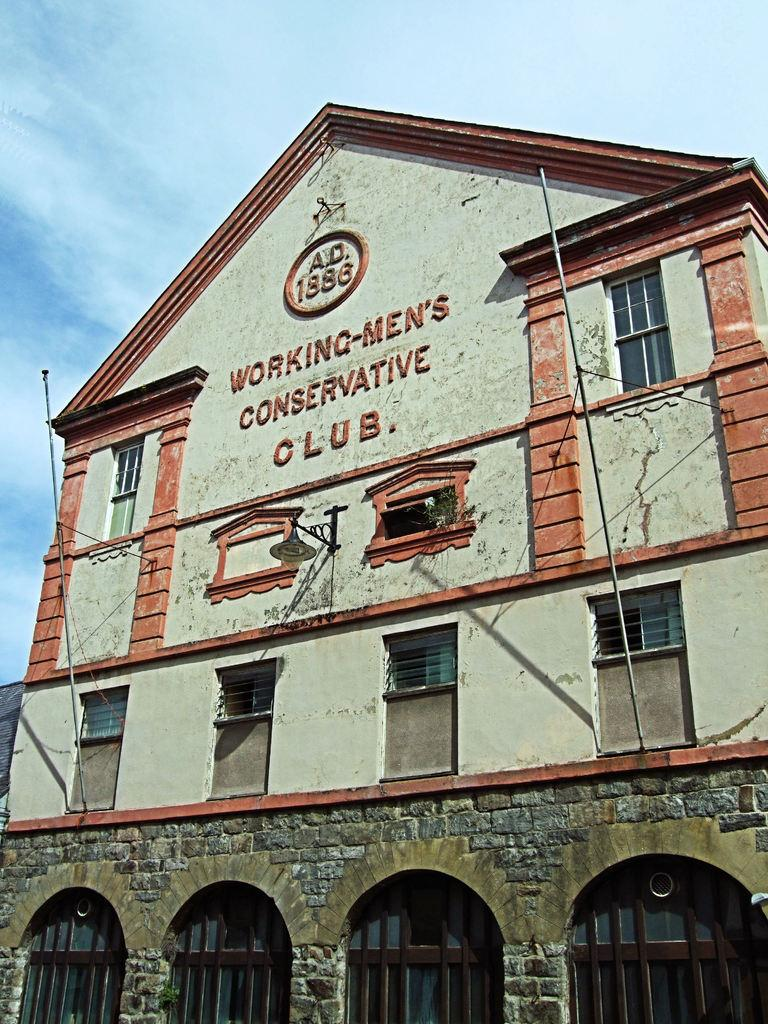What type of structure is present in the image? There is a building in the image. What feature of the building can be seen in the image? There are windows visible in the image. What else can be seen inside the building? There are lights visible in the image. What can be seen in the background of the image? The sky is visible in the background of the image. What is the condition of the sky in the image? Clouds are present in the sky. Can you tell me how many desks are visible in the image? There are no desks present in the image; it primarily features a building with windows and lights. What type of carriage can be seen in the image? There is no carriage present in the image. 